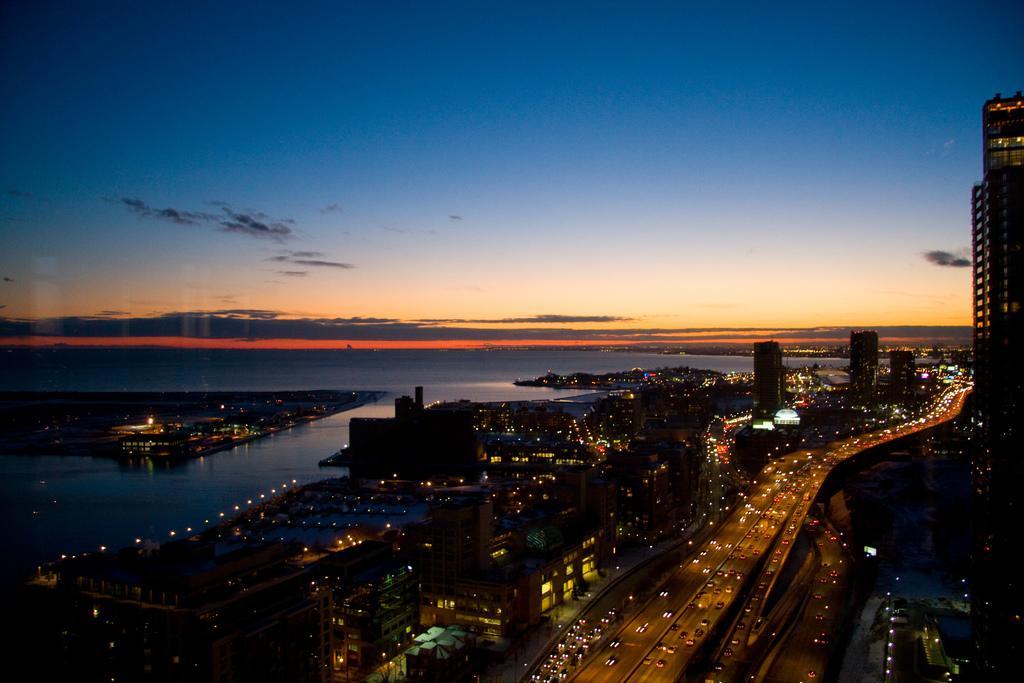Please provide a concise description of this image. It is the top view, this is the road in the middle of an image. On the right side there are buildings. On the left side it is water, at the top it's a sky. 